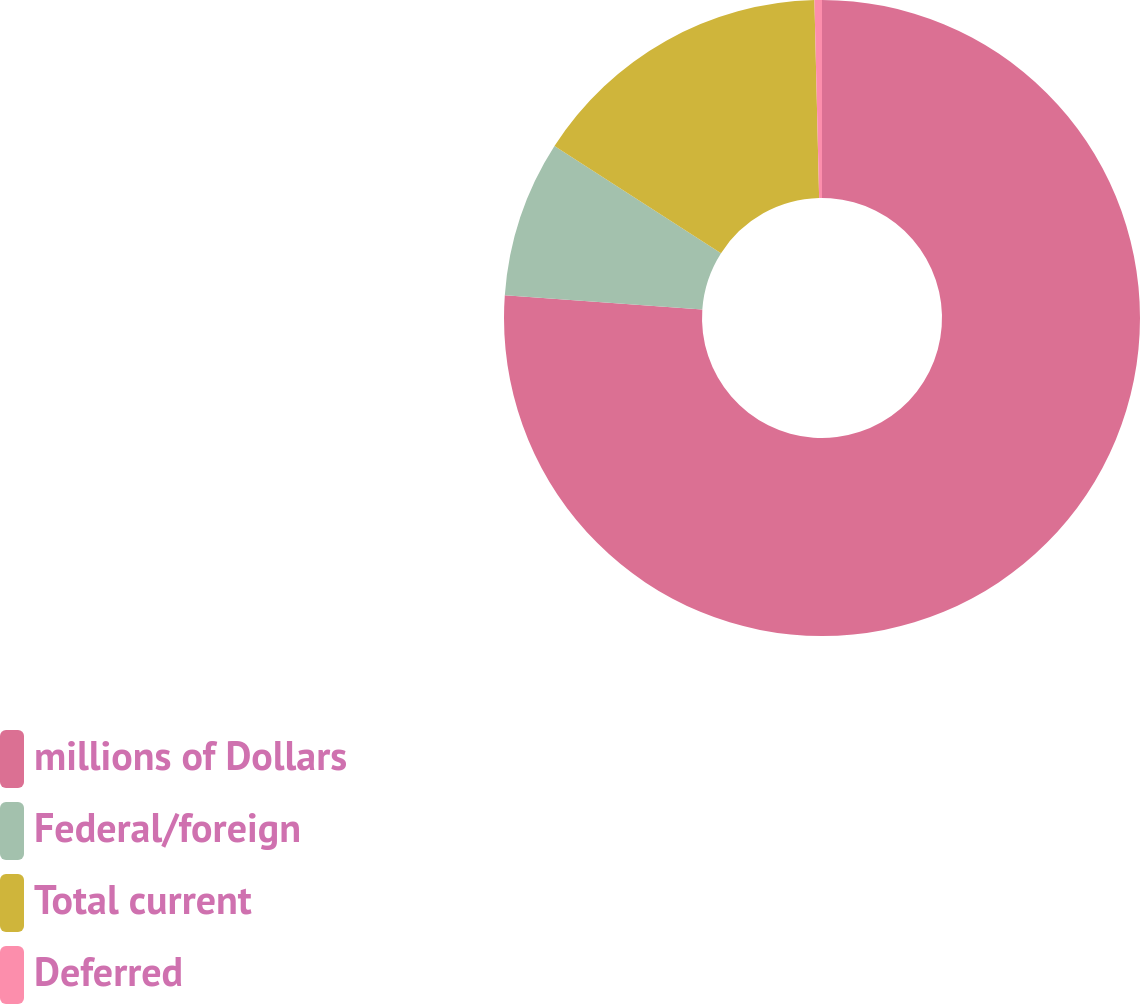Convert chart to OTSL. <chart><loc_0><loc_0><loc_500><loc_500><pie_chart><fcel>millions of Dollars<fcel>Federal/foreign<fcel>Total current<fcel>Deferred<nl><fcel>76.14%<fcel>7.95%<fcel>15.53%<fcel>0.38%<nl></chart> 